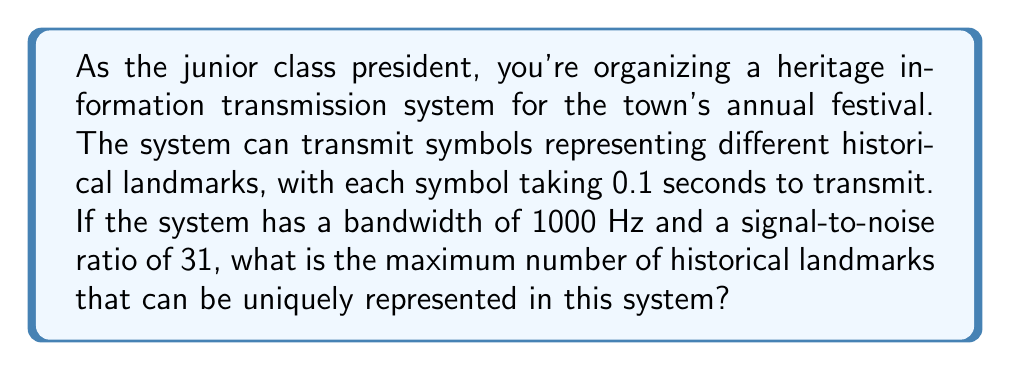Show me your answer to this math problem. To solve this problem, we need to use the Shannon-Hartley theorem to determine the channel capacity and then calculate the maximum number of unique symbols that can be transmitted.

1. The Shannon-Hartley theorem states that the channel capacity $C$ in bits per second is:

   $$C = B \log_2(1 + SNR)$$

   Where:
   $B$ is the bandwidth in Hz
   $SNR$ is the signal-to-noise ratio

2. Given:
   - Bandwidth $(B) = 1000$ Hz
   - Signal-to-noise ratio $(SNR) = 31$

3. Let's calculate the channel capacity:

   $$C = 1000 \log_2(1 + 31)$$
   $$C = 1000 \log_2(32)$$
   $$C = 1000 \cdot 5$$
   $$C = 5000 \text{ bits per second}$$

4. Now, we need to determine how many bits can be transmitted in 0.1 seconds:

   $$\text{Bits per symbol} = 5000 \text{ bits/s} \cdot 0.1 \text{ s} = 500 \text{ bits}$$

5. The number of unique symbols (historical landmarks) that can be represented is:

   $$N = 2^{\text{Bits per symbol}}$$
   $$N = 2^{500}$$

This is an extremely large number, far exceeding the number of historical landmarks in any town. In practice, we would use far fewer bits to represent each landmark, allowing for faster transmission and simpler encoding/decoding.
Answer: The maximum number of historical landmarks that can be uniquely represented is $2^{500}$. 